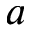Convert formula to latex. <formula><loc_0><loc_0><loc_500><loc_500>a</formula> 